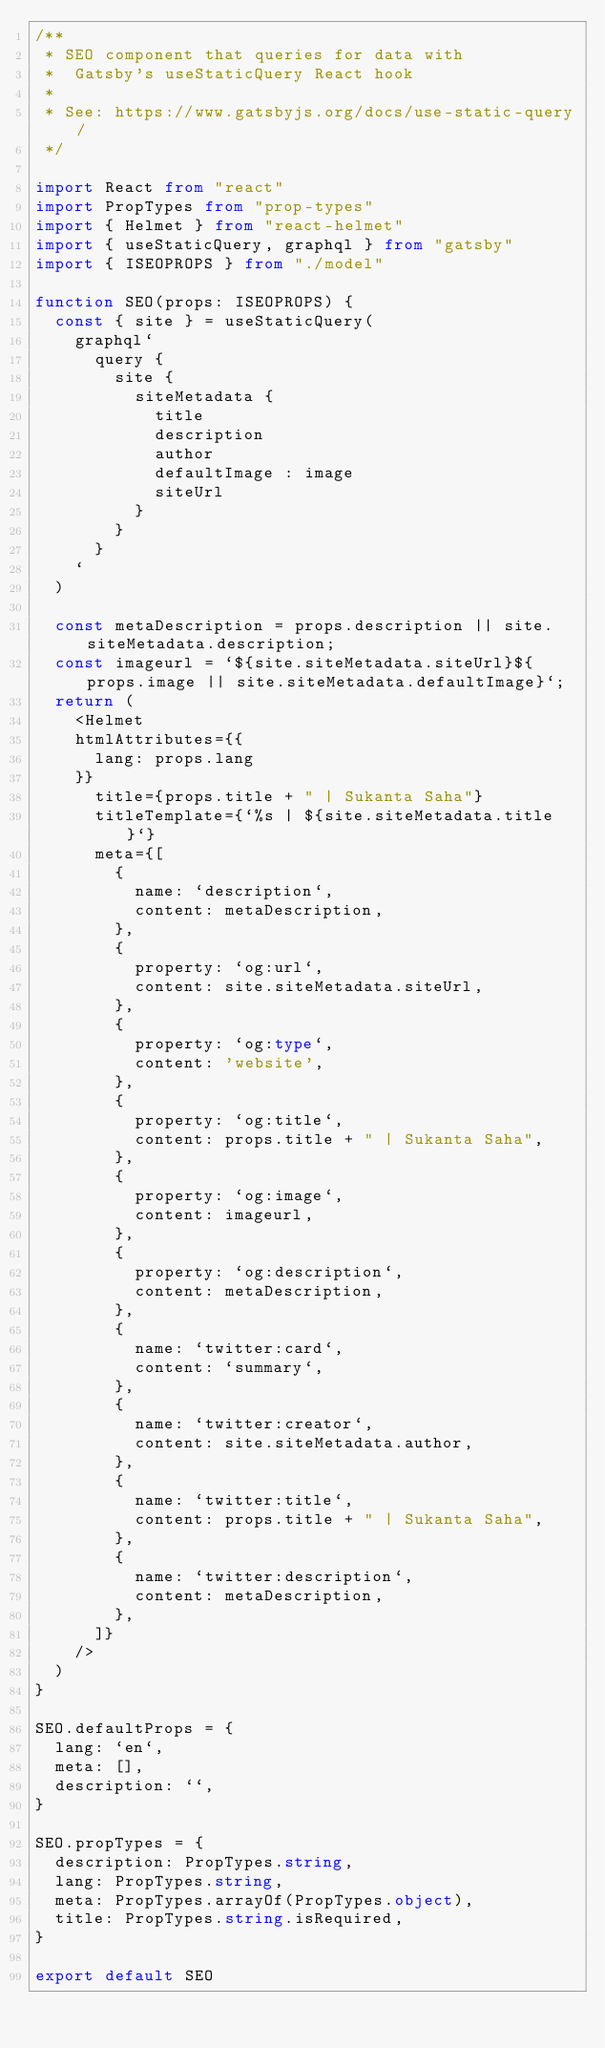<code> <loc_0><loc_0><loc_500><loc_500><_TypeScript_>/**
 * SEO component that queries for data with
 *  Gatsby's useStaticQuery React hook
 *
 * See: https://www.gatsbyjs.org/docs/use-static-query/
 */

import React from "react"
import PropTypes from "prop-types"
import { Helmet } from "react-helmet"
import { useStaticQuery, graphql } from "gatsby"
import { ISEOPROPS } from "./model"

function SEO(props: ISEOPROPS) {
  const { site } = useStaticQuery(
    graphql`
      query {
        site {
          siteMetadata {
            title
            description
            author
            defaultImage : image
            siteUrl
          }
        }
      }
    `
  )

  const metaDescription = props.description || site.siteMetadata.description;
  const imageurl = `${site.siteMetadata.siteUrl}${props.image || site.siteMetadata.defaultImage}`;
  return (
    <Helmet
    htmlAttributes={{
      lang: props.lang
    }}
      title={props.title + " | Sukanta Saha"}
      titleTemplate={`%s | ${site.siteMetadata.title}`}
      meta={[
        {
          name: `description`,
          content: metaDescription,
        },
        {
          property: `og:url`,
          content: site.siteMetadata.siteUrl,
        },
        {
          property: `og:type`,
          content: 'website',
        },
        {
          property: `og:title`,
          content: props.title + " | Sukanta Saha",
        },
        {
          property: `og:image`,
          content: imageurl,
        },
        {
          property: `og:description`,
          content: metaDescription,
        },
        {
          name: `twitter:card`,
          content: `summary`,
        },
        {
          name: `twitter:creator`,
          content: site.siteMetadata.author,
        },
        {
          name: `twitter:title`,
          content: props.title + " | Sukanta Saha",
        },
        {
          name: `twitter:description`,
          content: metaDescription,
        },
      ]}
    />
  )
}

SEO.defaultProps = {
  lang: `en`,
  meta: [],
  description: ``,
}

SEO.propTypes = {
  description: PropTypes.string,
  lang: PropTypes.string,
  meta: PropTypes.arrayOf(PropTypes.object),
  title: PropTypes.string.isRequired,
}

export default SEO
</code> 